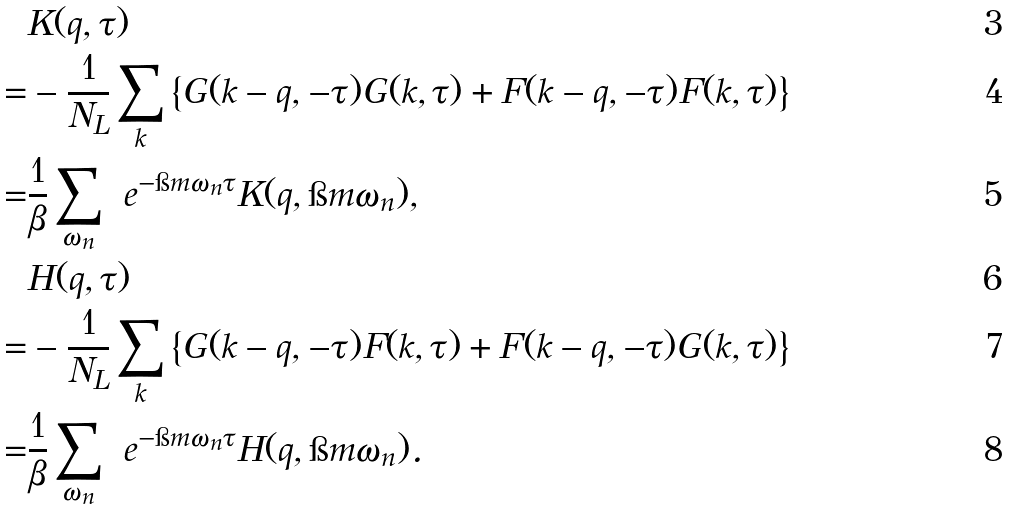<formula> <loc_0><loc_0><loc_500><loc_500>& K ( q , \tau ) \\ = & - \frac { 1 } { N _ { L } } \sum _ { k } \left \{ G ( k - q , - \tau ) G ( k , \tau ) + F ( k - q , - \tau ) F ( k , \tau ) \right \} \\ = & \frac { 1 } { \beta } \sum _ { \omega _ { n } } \ e ^ { - \i m \omega _ { n } \tau } K ( q , \i m \omega _ { n } ) , \\ & H ( q , \tau ) \\ = & - \frac { 1 } { N _ { L } } \sum _ { k } \left \{ G ( k - q , - \tau ) F ( k , \tau ) + F ( k - q , - \tau ) G ( k , \tau ) \right \} \\ = & \frac { 1 } { \beta } \sum _ { \omega _ { n } } \ e ^ { - \i m \omega _ { n } \tau } H ( q , \i m \omega _ { n } ) .</formula> 